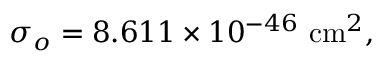<formula> <loc_0><loc_0><loc_500><loc_500>\sigma _ { o } = 8 . 6 1 1 \times 1 0 ^ { - 4 6 } c m ^ { 2 } ,</formula> 